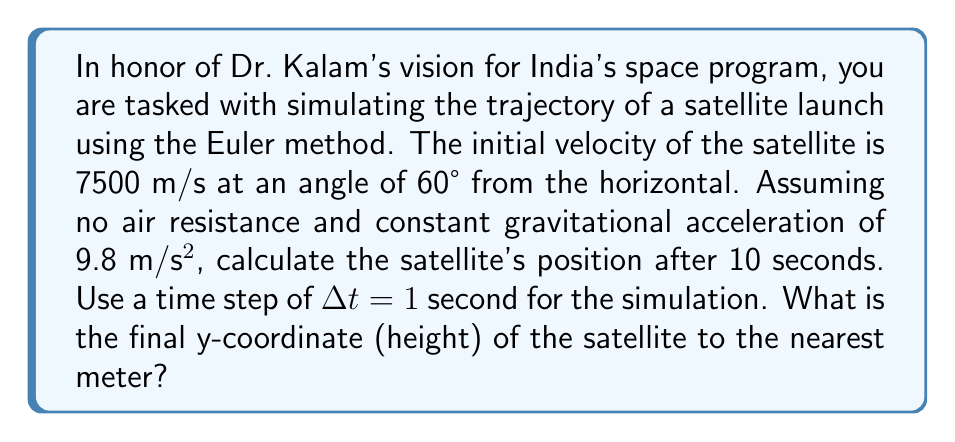Can you solve this math problem? Let's approach this step-by-step using the Euler method:

1) First, we need to break down the initial velocity into x and y components:
   $v_{x0} = 7500 \cos(60°) = 3750$ m/s
   $v_{y0} = 7500 \sin(60°) = 6495$ m/s

2) We'll use the Euler method equations:
   $x_{n+1} = x_n + v_{xn} \Delta t$
   $y_{n+1} = y_n + v_{yn} \Delta t$
   $v_{xn+1} = v_{xn}$
   $v_{yn+1} = v_{yn} - g \Delta t$

3) Let's create a table to simulate for 10 seconds:

   $$
   \begin{array}{|c|c|c|c|c|}
   \hline
   t (s) & x (m) & y (m) & v_x (m/s) & v_y (m/s) \\
   \hline
   0 & 0 & 0 & 3750 & 6495 \\
   1 & 3750 & 6495 & 3750 & 6485.2 \\
   2 & 7500 & 12980.2 & 3750 & 6475.4 \\
   3 & 11250 & 19455.6 & 3750 & 6465.6 \\
   4 & 15000 & 25921.2 & 3750 & 6455.8 \\
   5 & 18750 & 32377 & 3750 & 6446 \\
   6 & 22500 & 38823 & 3750 & 6436.2 \\
   7 & 26250 & 45259.2 & 3750 & 6426.4 \\
   8 & 30000 & 51685.6 & 3750 & 6416.6 \\
   9 & 33750 & 58102.2 & 3750 & 6406.8 \\
   10 & 37500 & 64509 & 3750 & 6397 \\
   \hline
   \end{array}
   $$

4) From the table, we can see that after 10 seconds, the y-coordinate (height) is 64509 meters.

5) Rounding to the nearest meter, we get 64509 meters.
Answer: 64509 meters 